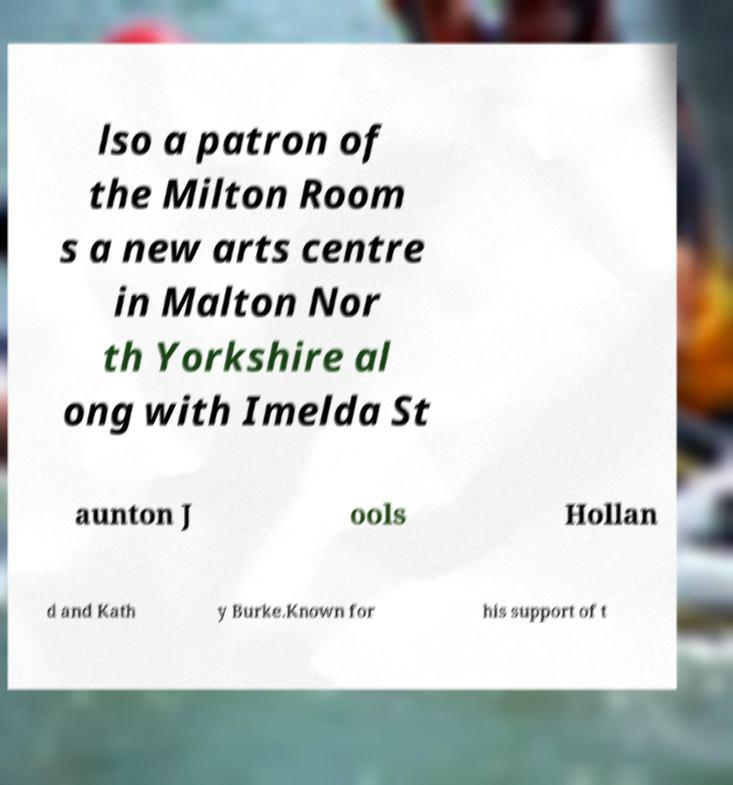I need the written content from this picture converted into text. Can you do that? lso a patron of the Milton Room s a new arts centre in Malton Nor th Yorkshire al ong with Imelda St aunton J ools Hollan d and Kath y Burke.Known for his support of t 